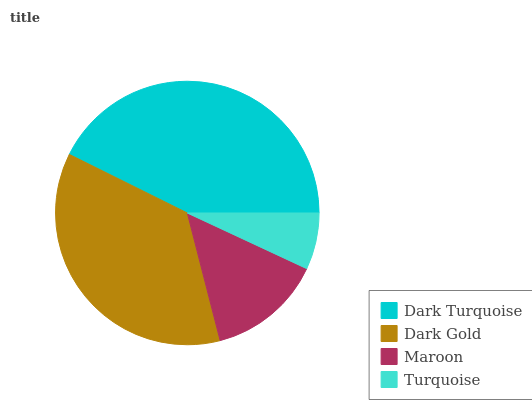Is Turquoise the minimum?
Answer yes or no. Yes. Is Dark Turquoise the maximum?
Answer yes or no. Yes. Is Dark Gold the minimum?
Answer yes or no. No. Is Dark Gold the maximum?
Answer yes or no. No. Is Dark Turquoise greater than Dark Gold?
Answer yes or no. Yes. Is Dark Gold less than Dark Turquoise?
Answer yes or no. Yes. Is Dark Gold greater than Dark Turquoise?
Answer yes or no. No. Is Dark Turquoise less than Dark Gold?
Answer yes or no. No. Is Dark Gold the high median?
Answer yes or no. Yes. Is Maroon the low median?
Answer yes or no. Yes. Is Turquoise the high median?
Answer yes or no. No. Is Dark Turquoise the low median?
Answer yes or no. No. 